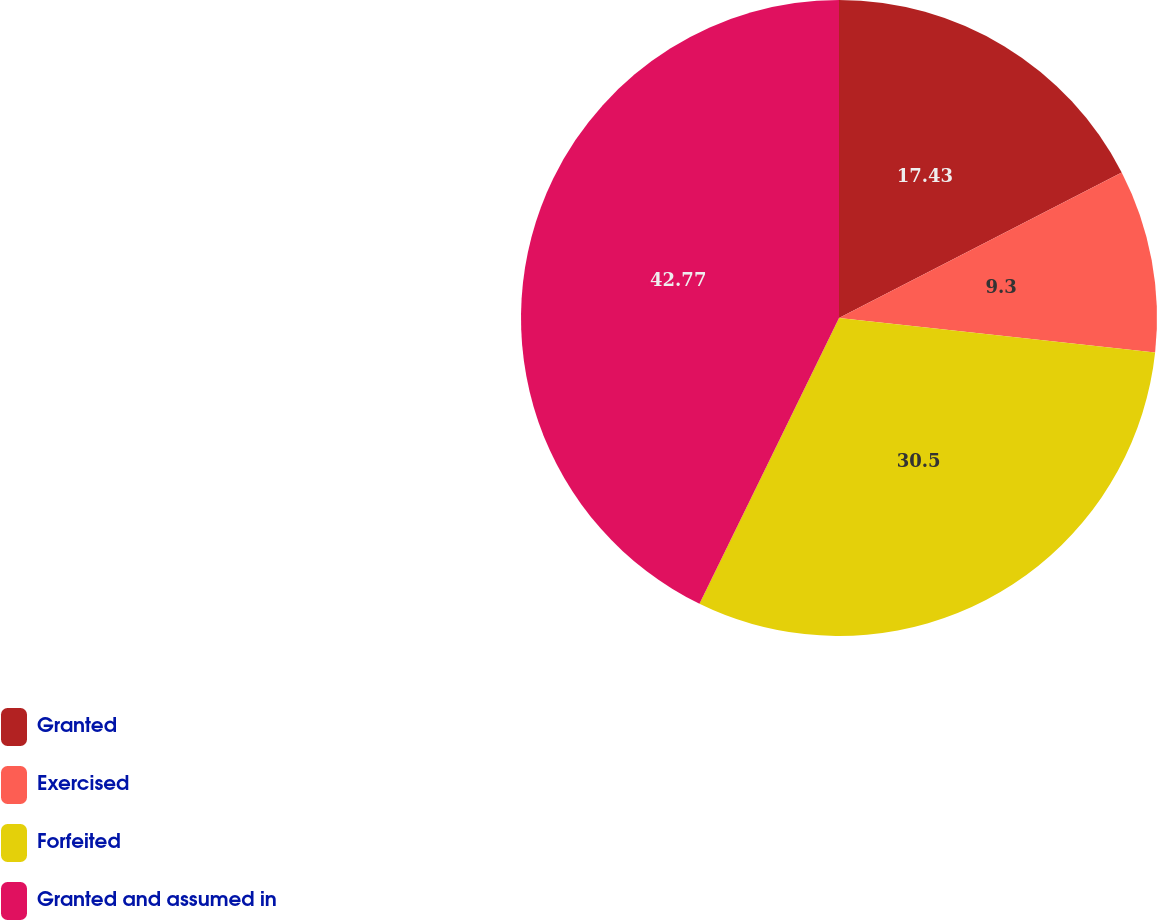<chart> <loc_0><loc_0><loc_500><loc_500><pie_chart><fcel>Granted<fcel>Exercised<fcel>Forfeited<fcel>Granted and assumed in<nl><fcel>17.43%<fcel>9.3%<fcel>30.5%<fcel>42.77%<nl></chart> 